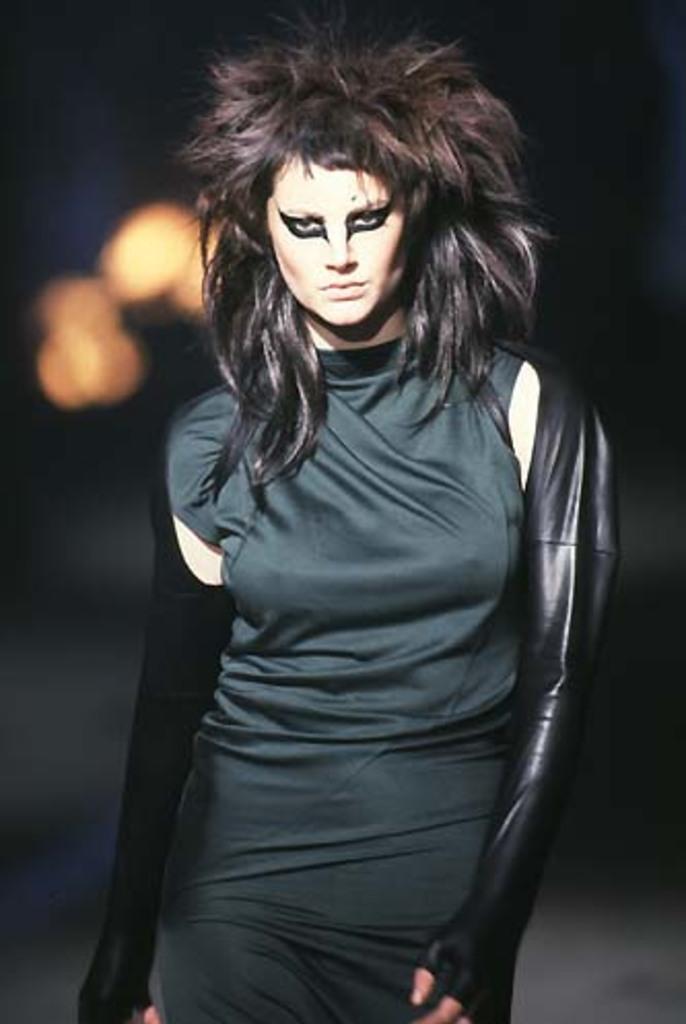Please provide a concise description of this image. In this image we can see a woman is standing, she is wearing the black color dress, at back here is the light. 